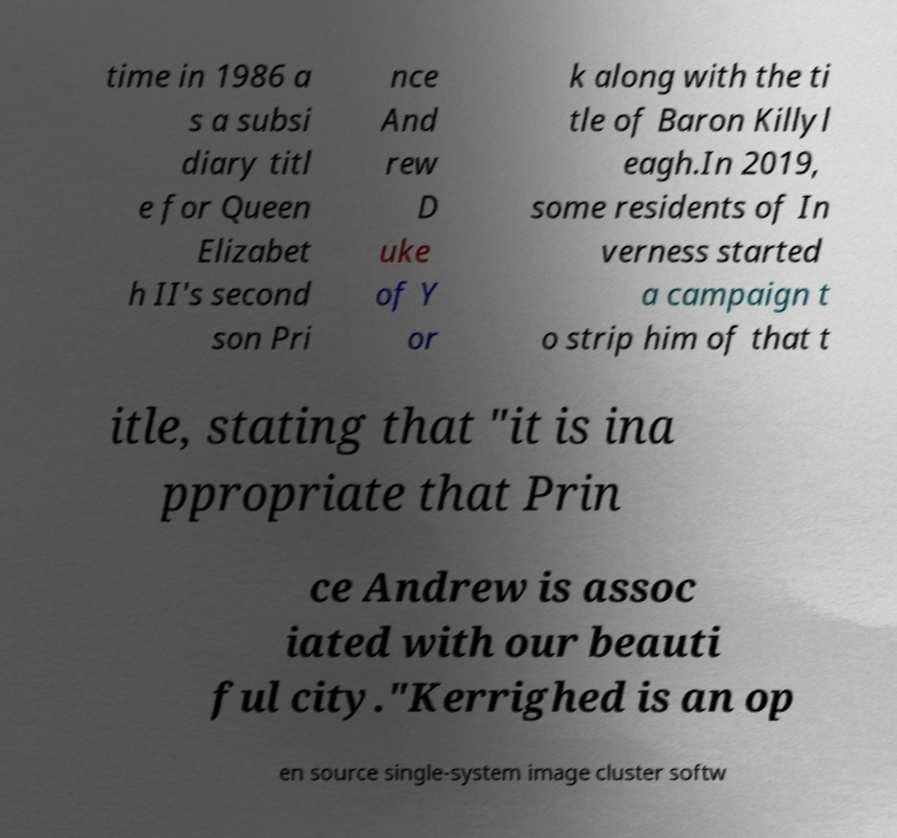Could you assist in decoding the text presented in this image and type it out clearly? time in 1986 a s a subsi diary titl e for Queen Elizabet h II's second son Pri nce And rew D uke of Y or k along with the ti tle of Baron Killyl eagh.In 2019, some residents of In verness started a campaign t o strip him of that t itle, stating that "it is ina ppropriate that Prin ce Andrew is assoc iated with our beauti ful city."Kerrighed is an op en source single-system image cluster softw 